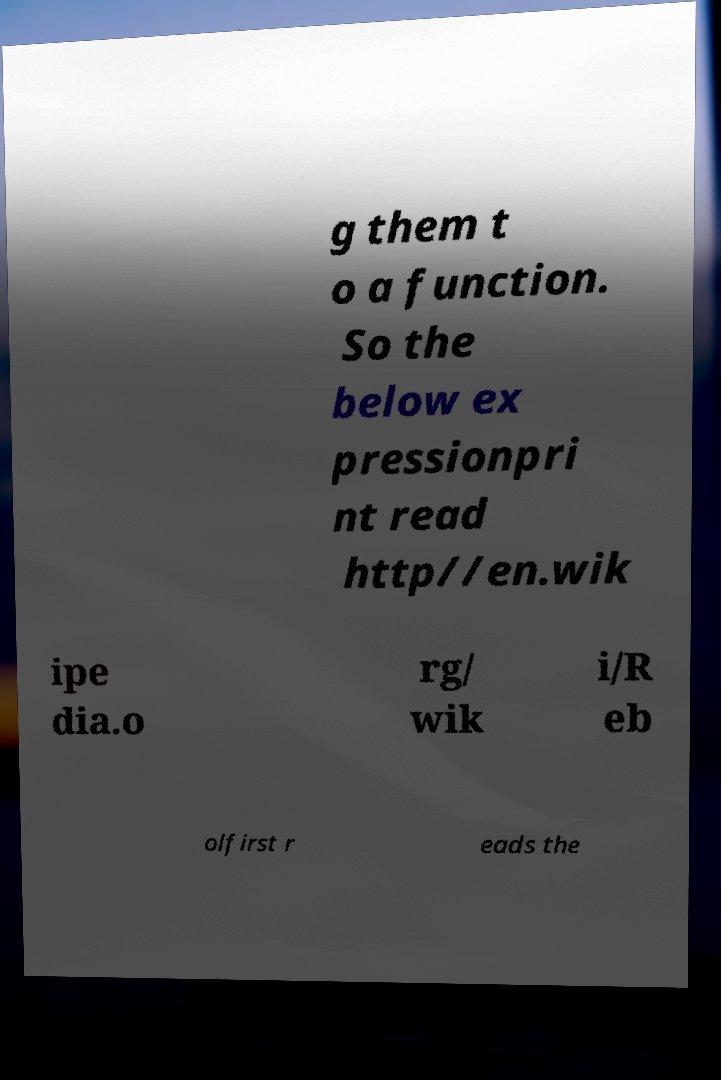Please read and relay the text visible in this image. What does it say? g them t o a function. So the below ex pressionpri nt read http//en.wik ipe dia.o rg/ wik i/R eb olfirst r eads the 